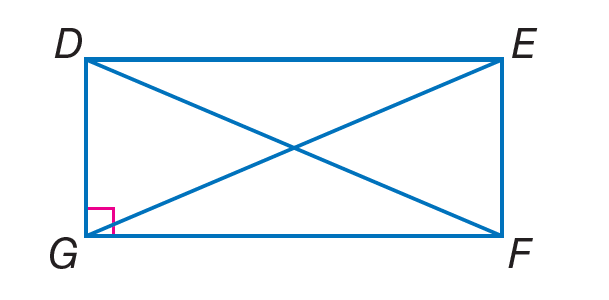Question: Quadrilateral D E F G is a rectangle. If D E = 14 + 2 x and G F = 4(x - 3) + 6, find G F.
Choices:
A. 15
B. 28
C. 34
D. 40
Answer with the letter. Answer: C Question: Quadrilateral D E F G is a rectangle. If D F = 2(x + 5) - 7 and E G = 3(x - 2), find E G.
Choices:
A. 6.5
B. 10
C. 21
D. 30
Answer with the letter. Answer: C 